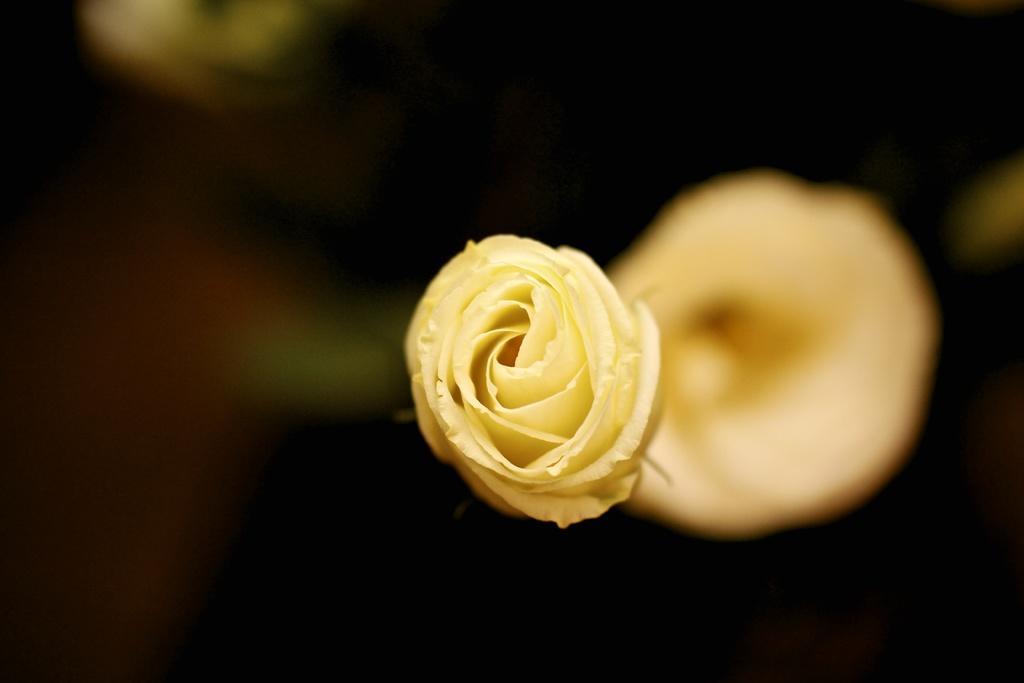Can you describe this image briefly? In this image I can see a flower which is yellow in color. I can see the blurry background which is black and yellow in color. 